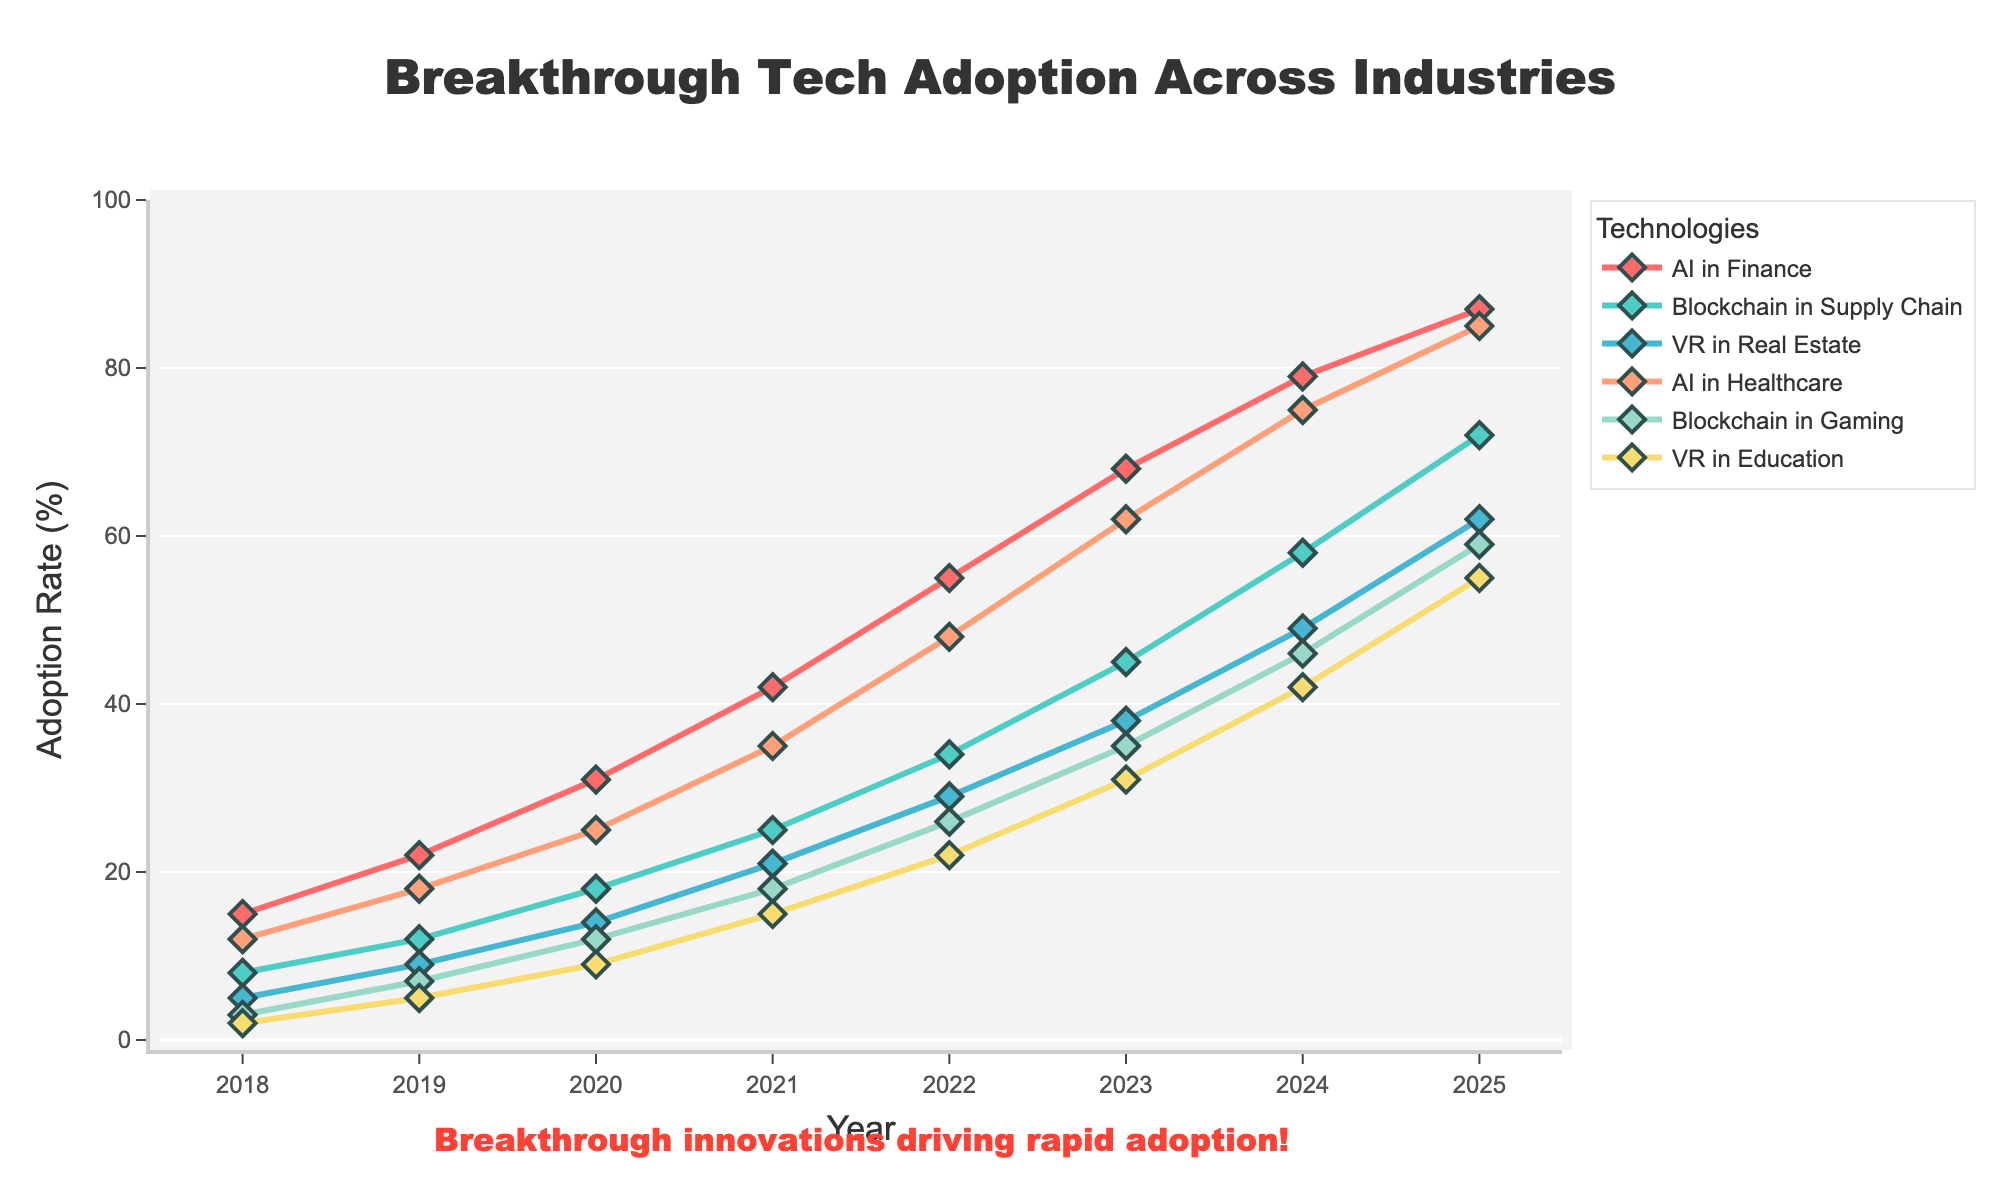What's the overall trend in AI adoption in Finance from 2018 to 2025? The AI adoption in Finance shows a consistent increase from 15% in 2018 to 87% in 2025. There are no decreases observed in any year during this period, indicating a strong upward trend.
Answer: Upward trend How does the adoption rate of Blockchain in Supply Chain compare between 2018 and 2025? In 2018, the adoption rate of Blockchain in Supply Chain was 8%, while in 2025 it rose to 72%. The increase is 64 percentage points over this period.
Answer: 72% in 2025, up from 8% in 2018 Which industry and technology combination had the highest adoption rate in 2023? By examining the adoption rates for 2023, AI in Finance had the highest adoption rate at 68%. This is higher than the adoption rates of other technology and industry combinations for that year.
Answer: AI in Finance What is the difference in adoption rates between VR in Real Estate and VR in Education in 2022? In 2022, VR in Real Estate had an adoption rate of 29%, and VR in Education had an adoption rate of 22%. The difference in adoption rates is calculated as 29% - 22% = 7%.
Answer: 7% Considering the trend from 2018 to 2025, how does the growth of AI in Healthcare compare to Blockchain in Gaming? AI in Healthcare grew from 12% in 2018 to 85% in 2025, an increase of 73 percentage points. Blockchain in Gaming grew from 3% to 59% in the same period, which is an increase of 56 percentage points. AI in Healthcare shows a larger absolute increase.
Answer: AI in Healthcare grew by 73%, Blockchain in Gaming by 56% In which year did the adoption rate of Blockchain in Supply Chain first surpass the 50% mark? By examining the graph, Blockchain in Supply Chain first surpassed the 50% mark in 2024 when the adoption rate reached 58%. Prior to this, in 2023, the adoption rate was 45%.
Answer: 2024 Is the adoption of VR in Education growing at a faster rate than VR in Real Estate from 2018 to 2025? In 2018, VR in Education started at 2% and grew to 55% in 2025, an increase of 53 percentage points. VR in Real Estate started at 5% in 2018 and grew to 62% in 2025, an increase of 57 percentage points. While both are increasing significantly, VR in Real Estate has a slightly higher growth rate.
Answer: No, VR in Real Estate grew faster What is the average adoption rate of AI in Healthcare from 2018 to 2025? Summing up the adoption rates of AI in Healthcare from 2018 to 2025 (12, 18, 25, 35, 48, 62, 75, 85) provides a total of 360. Dividing this sum by the number of years (8) gives an average adoption rate of 360/8 = 45%.
Answer: 45% Among AI in Finance, Blockchain in Supply Chain, and VR in Real Estate, which had the lowest adoption rate in 2020? In 2020, AI in Finance had an adoption rate of 31%, Blockchain in Supply Chain had an adoption rate of 18%, and VR in Real Estate had an adoption rate of 14%. VR in Real Estate had the lowest adoption rate among the three.
Answer: VR in Real Estate 